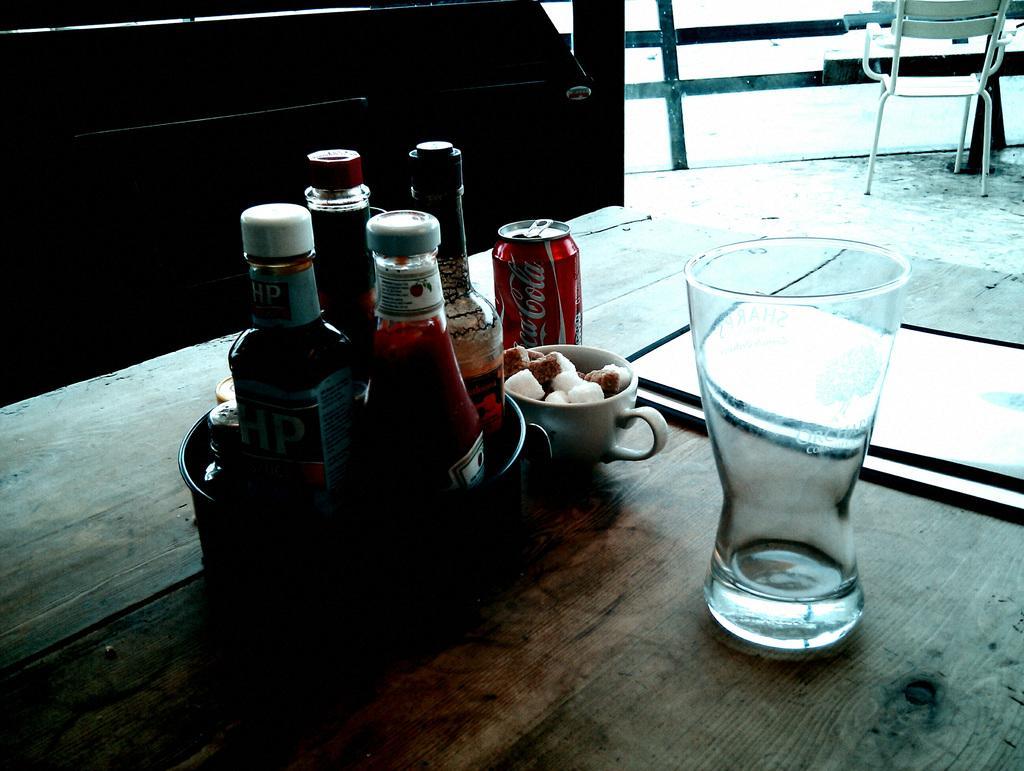Describe this image in one or two sentences. Here we can see a group of bottles placed in a bowl that is placed on the table and there is a glass present on the table and there is a cup and there is a tin present on the table and on the right top side we can see a chair present 